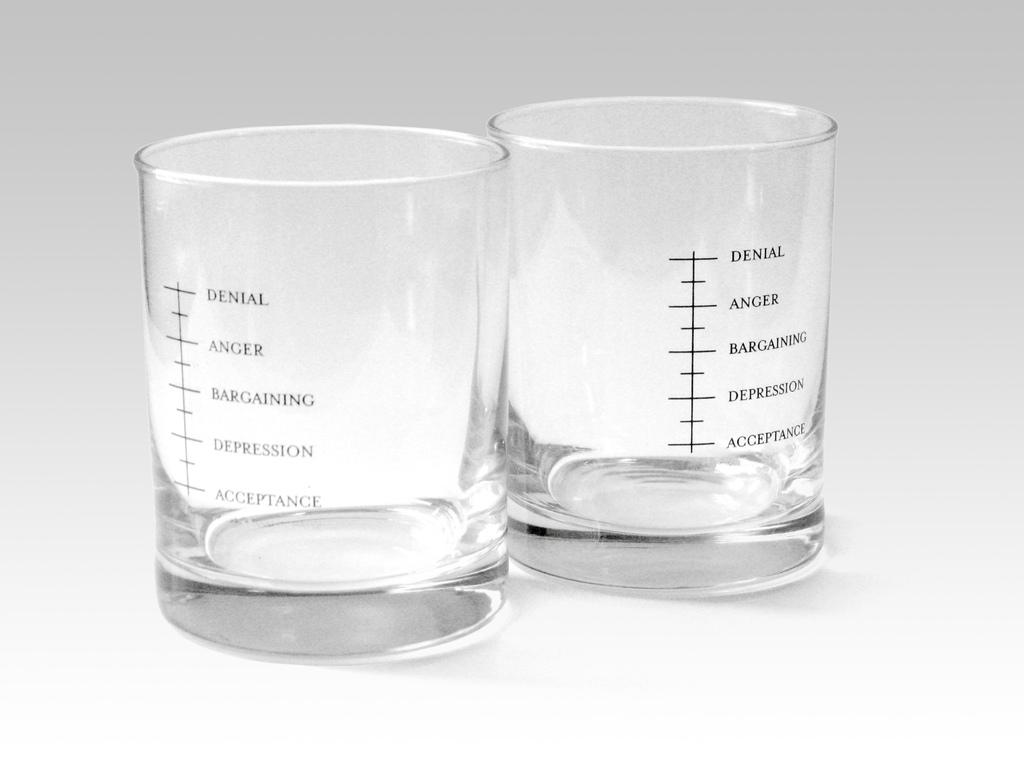Provide a one-sentence caption for the provided image. Shot glasses marked with stages of grief with denial at the top. 